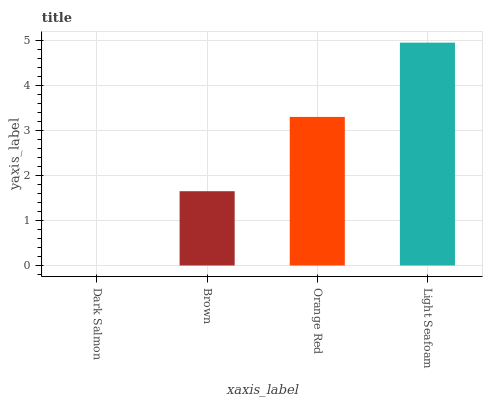Is Dark Salmon the minimum?
Answer yes or no. Yes. Is Light Seafoam the maximum?
Answer yes or no. Yes. Is Brown the minimum?
Answer yes or no. No. Is Brown the maximum?
Answer yes or no. No. Is Brown greater than Dark Salmon?
Answer yes or no. Yes. Is Dark Salmon less than Brown?
Answer yes or no. Yes. Is Dark Salmon greater than Brown?
Answer yes or no. No. Is Brown less than Dark Salmon?
Answer yes or no. No. Is Orange Red the high median?
Answer yes or no. Yes. Is Brown the low median?
Answer yes or no. Yes. Is Light Seafoam the high median?
Answer yes or no. No. Is Dark Salmon the low median?
Answer yes or no. No. 